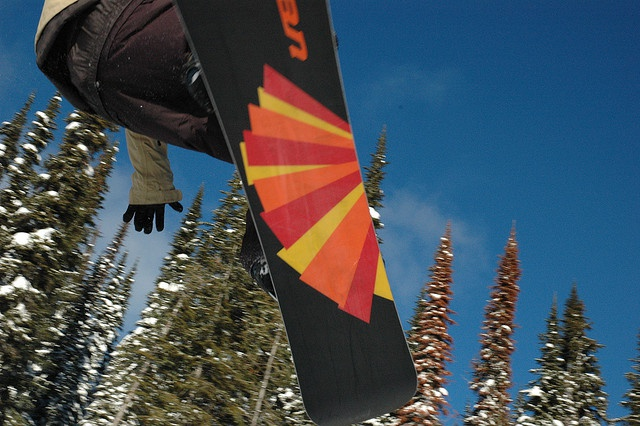Describe the objects in this image and their specific colors. I can see snowboard in blue, black, red, brown, and orange tones and people in blue, black, and gray tones in this image. 